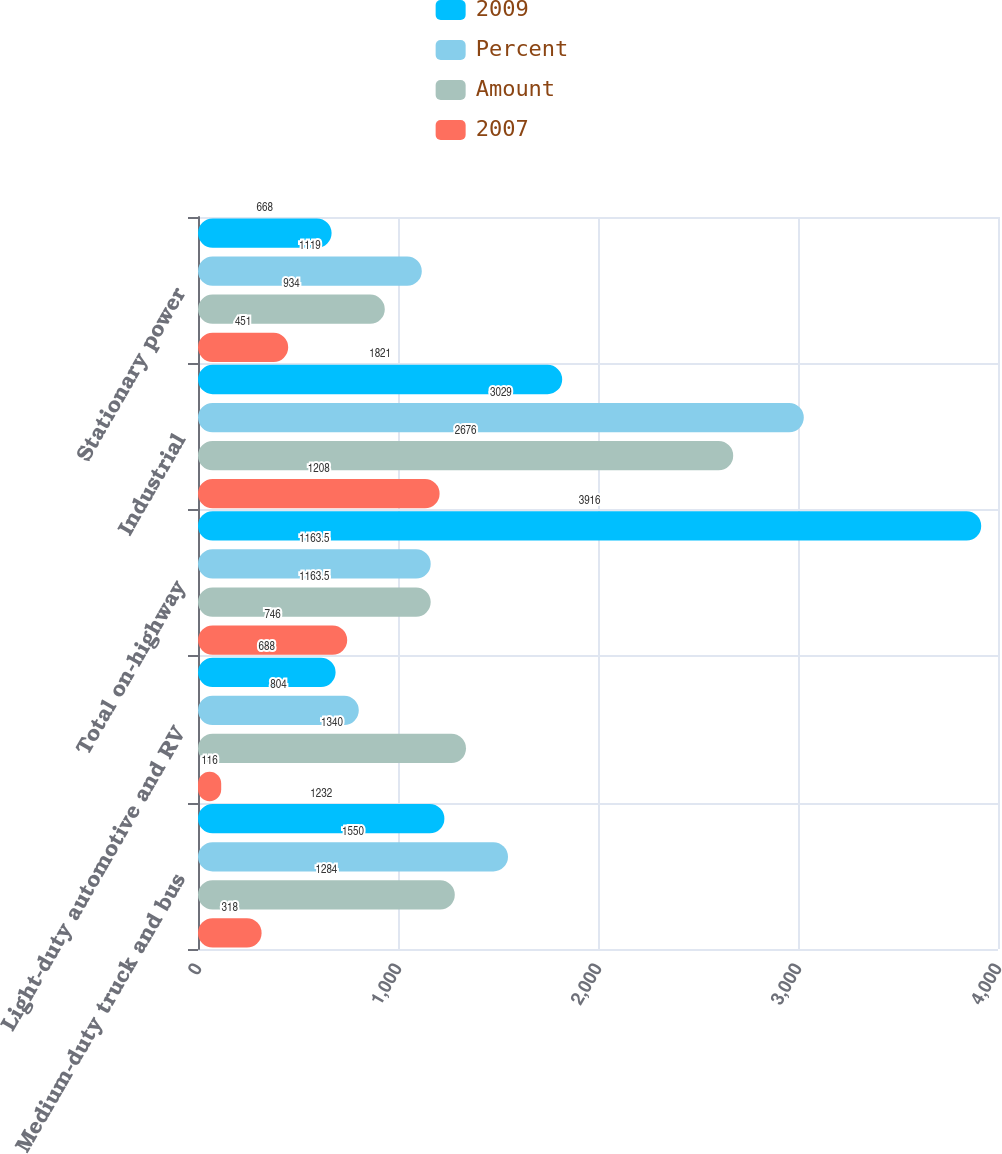Convert chart. <chart><loc_0><loc_0><loc_500><loc_500><stacked_bar_chart><ecel><fcel>Medium-duty truck and bus<fcel>Light-duty automotive and RV<fcel>Total on-highway<fcel>Industrial<fcel>Stationary power<nl><fcel>2009<fcel>1232<fcel>688<fcel>3916<fcel>1821<fcel>668<nl><fcel>Percent<fcel>1550<fcel>804<fcel>1163.5<fcel>3029<fcel>1119<nl><fcel>Amount<fcel>1284<fcel>1340<fcel>1163.5<fcel>2676<fcel>934<nl><fcel>2007<fcel>318<fcel>116<fcel>746<fcel>1208<fcel>451<nl></chart> 